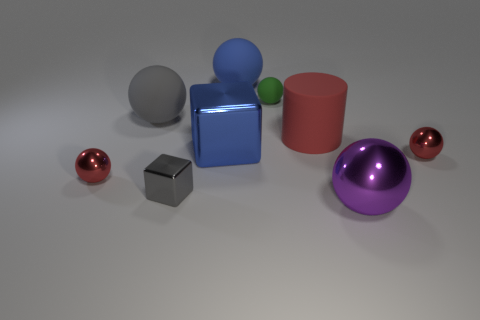Is there anything else that has the same color as the large metal sphere?
Provide a short and direct response. No. There is a large gray thing; what shape is it?
Keep it short and to the point. Sphere. How big is the thing that is both right of the gray block and left of the blue matte object?
Make the answer very short. Large. What is the material of the gray ball behind the large metallic ball?
Provide a succinct answer. Rubber. Is the color of the big shiny cube the same as the rubber thing behind the small green matte ball?
Your answer should be compact. Yes. How many things are balls that are on the right side of the green sphere or metallic objects that are behind the big purple thing?
Your response must be concise. 5. There is a sphere that is both to the right of the big cylinder and behind the purple sphere; what is its color?
Your answer should be compact. Red. Is the number of blue metallic cylinders greater than the number of big metal objects?
Provide a succinct answer. No. There is a small red thing that is to the right of the purple thing; does it have the same shape as the purple metallic thing?
Give a very brief answer. Yes. How many matte things are blue objects or tiny red things?
Keep it short and to the point. 1. 